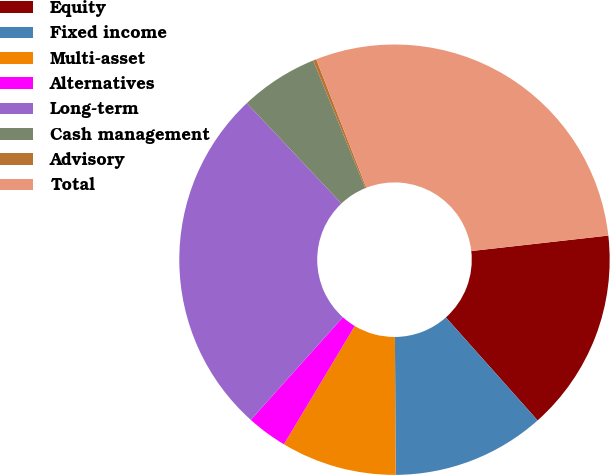Convert chart to OTSL. <chart><loc_0><loc_0><loc_500><loc_500><pie_chart><fcel>Equity<fcel>Fixed income<fcel>Multi-asset<fcel>Alternatives<fcel>Long-term<fcel>Cash management<fcel>Advisory<fcel>Total<nl><fcel>15.21%<fcel>11.49%<fcel>8.68%<fcel>3.05%<fcel>26.33%<fcel>5.87%<fcel>0.24%<fcel>29.14%<nl></chart> 